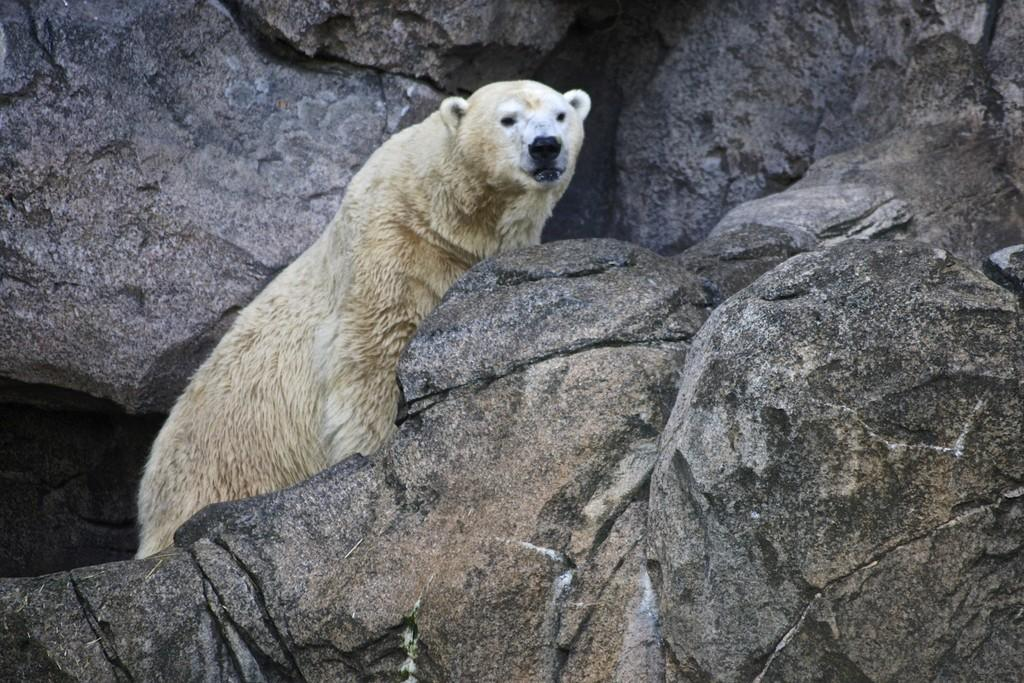What type of animal is in the image? There is a white polar bear in the image. Where is the polar bear located in the image? The polar bear is hiding behind a rock. What shape is the polar bear's nose in the image? The image does not provide enough detail to determine the shape of the polar bear's nose. How does the polar bear express disgust in the image? The image does not show the polar bear expressing any emotions, including disgust. 